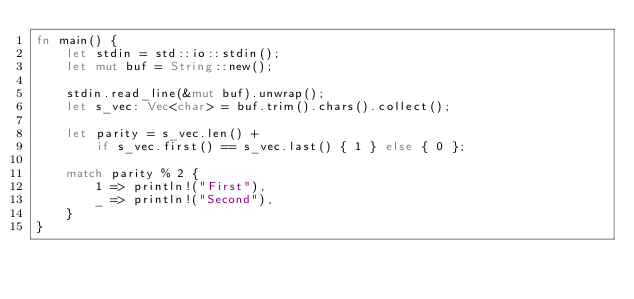Convert code to text. <code><loc_0><loc_0><loc_500><loc_500><_Rust_>fn main() {
    let stdin = std::io::stdin();
    let mut buf = String::new();

    stdin.read_line(&mut buf).unwrap();
    let s_vec: Vec<char> = buf.trim().chars().collect();

    let parity = s_vec.len() +
        if s_vec.first() == s_vec.last() { 1 } else { 0 };

    match parity % 2 {
        1 => println!("First"),
        _ => println!("Second"),
    }
}
</code> 